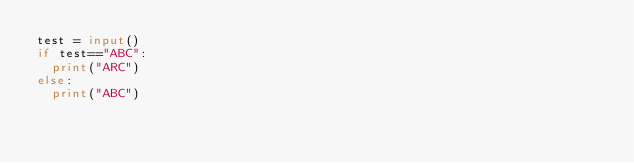<code> <loc_0><loc_0><loc_500><loc_500><_Python_>test = input()
if test=="ABC":
  print("ARC")
else:
  print("ABC")</code> 